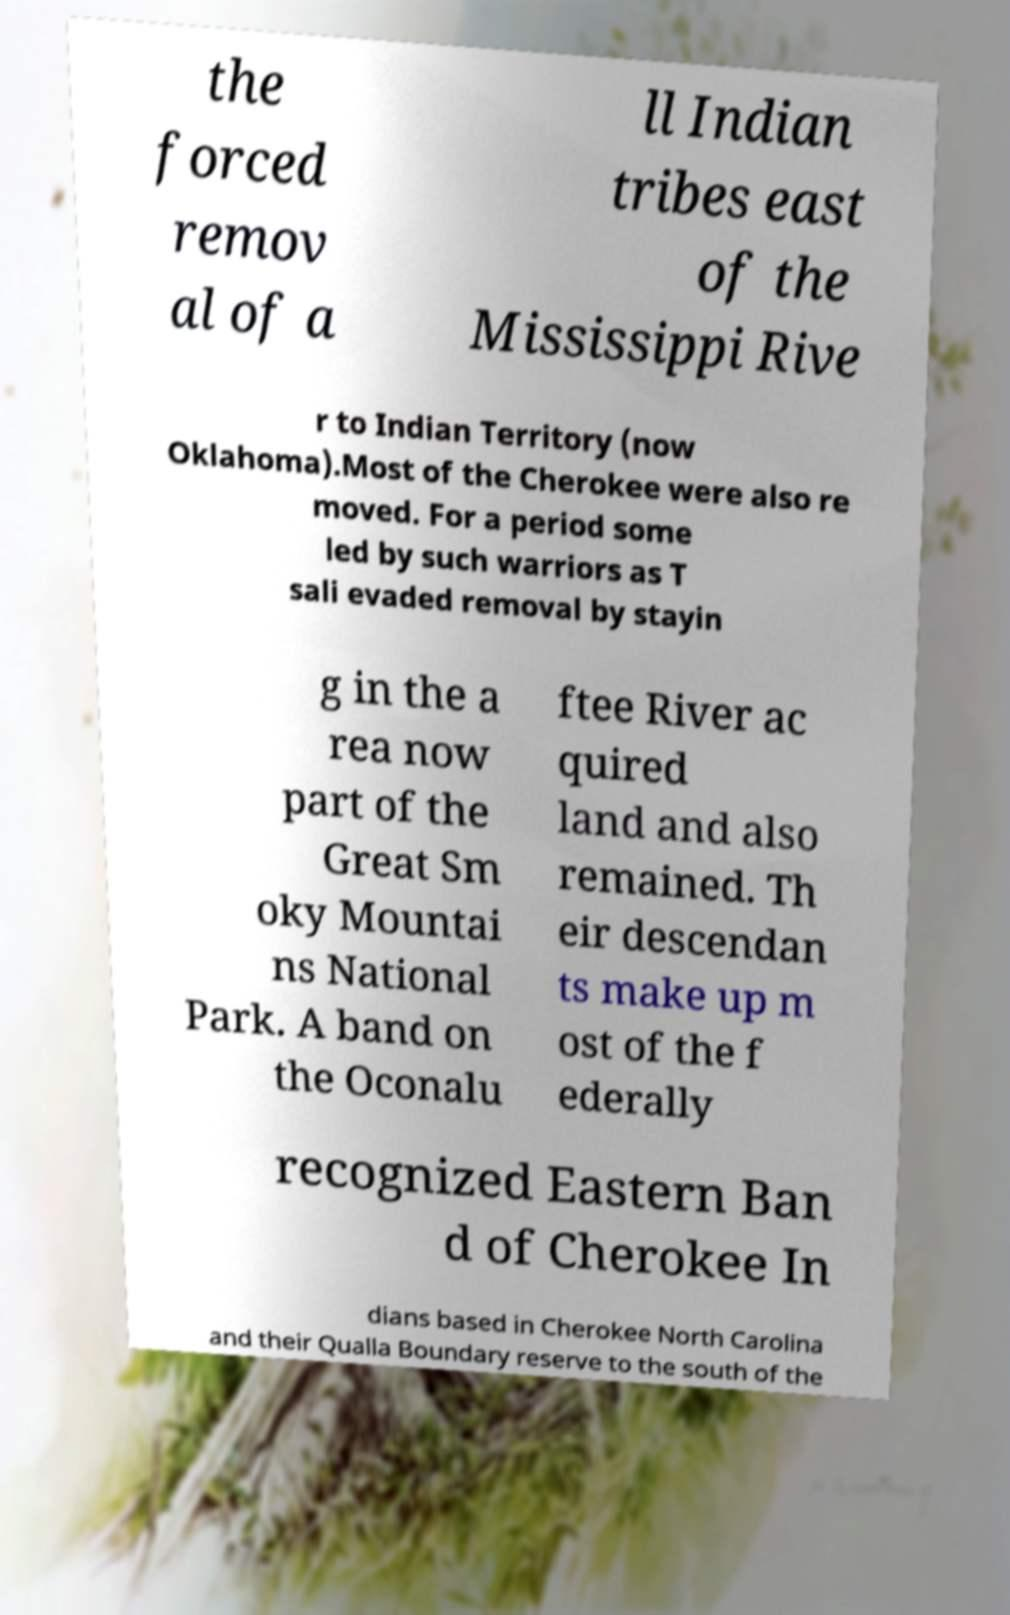There's text embedded in this image that I need extracted. Can you transcribe it verbatim? the forced remov al of a ll Indian tribes east of the Mississippi Rive r to Indian Territory (now Oklahoma).Most of the Cherokee were also re moved. For a period some led by such warriors as T sali evaded removal by stayin g in the a rea now part of the Great Sm oky Mountai ns National Park. A band on the Oconalu ftee River ac quired land and also remained. Th eir descendan ts make up m ost of the f ederally recognized Eastern Ban d of Cherokee In dians based in Cherokee North Carolina and their Qualla Boundary reserve to the south of the 